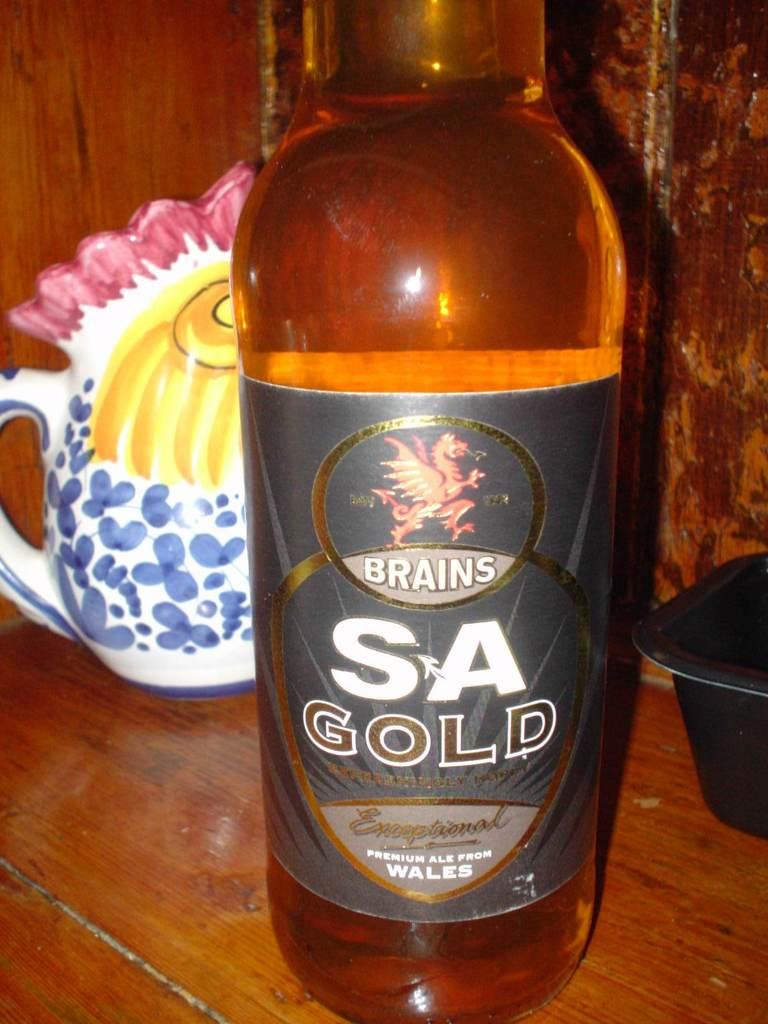<image>
Offer a succinct explanation of the picture presented. A bottle of Brains SA Gold sits on a table in front of a chicken-shaped pitcher. 